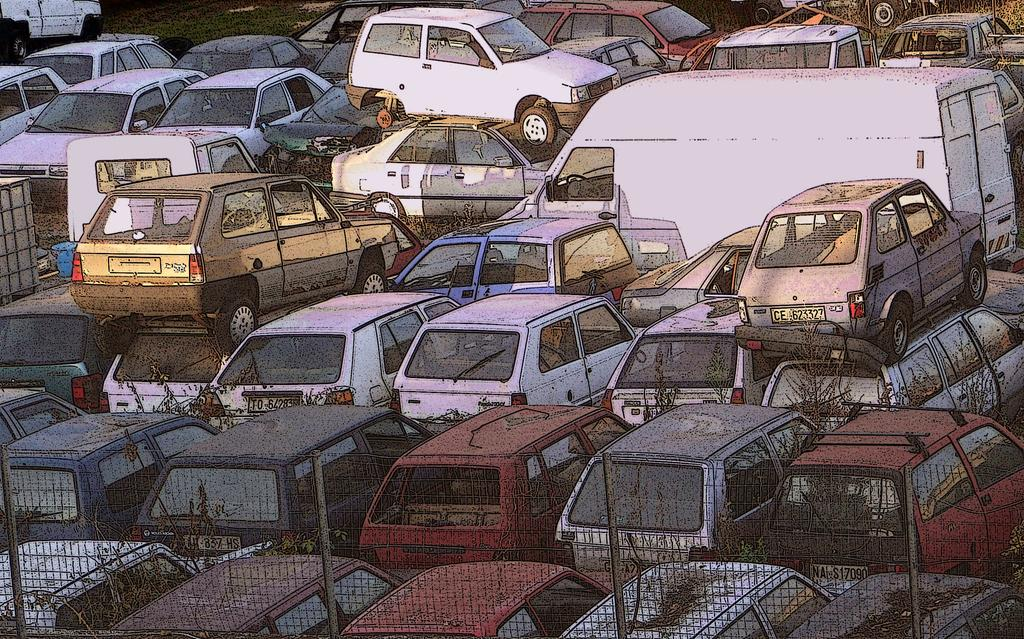What types of objects can be seen in the image? There are vehicles and plants in the image. What material is present in the image? There is mesh in the image. What is the size of the grape in the image? There is no grape present in the image, so its size cannot be determined. 